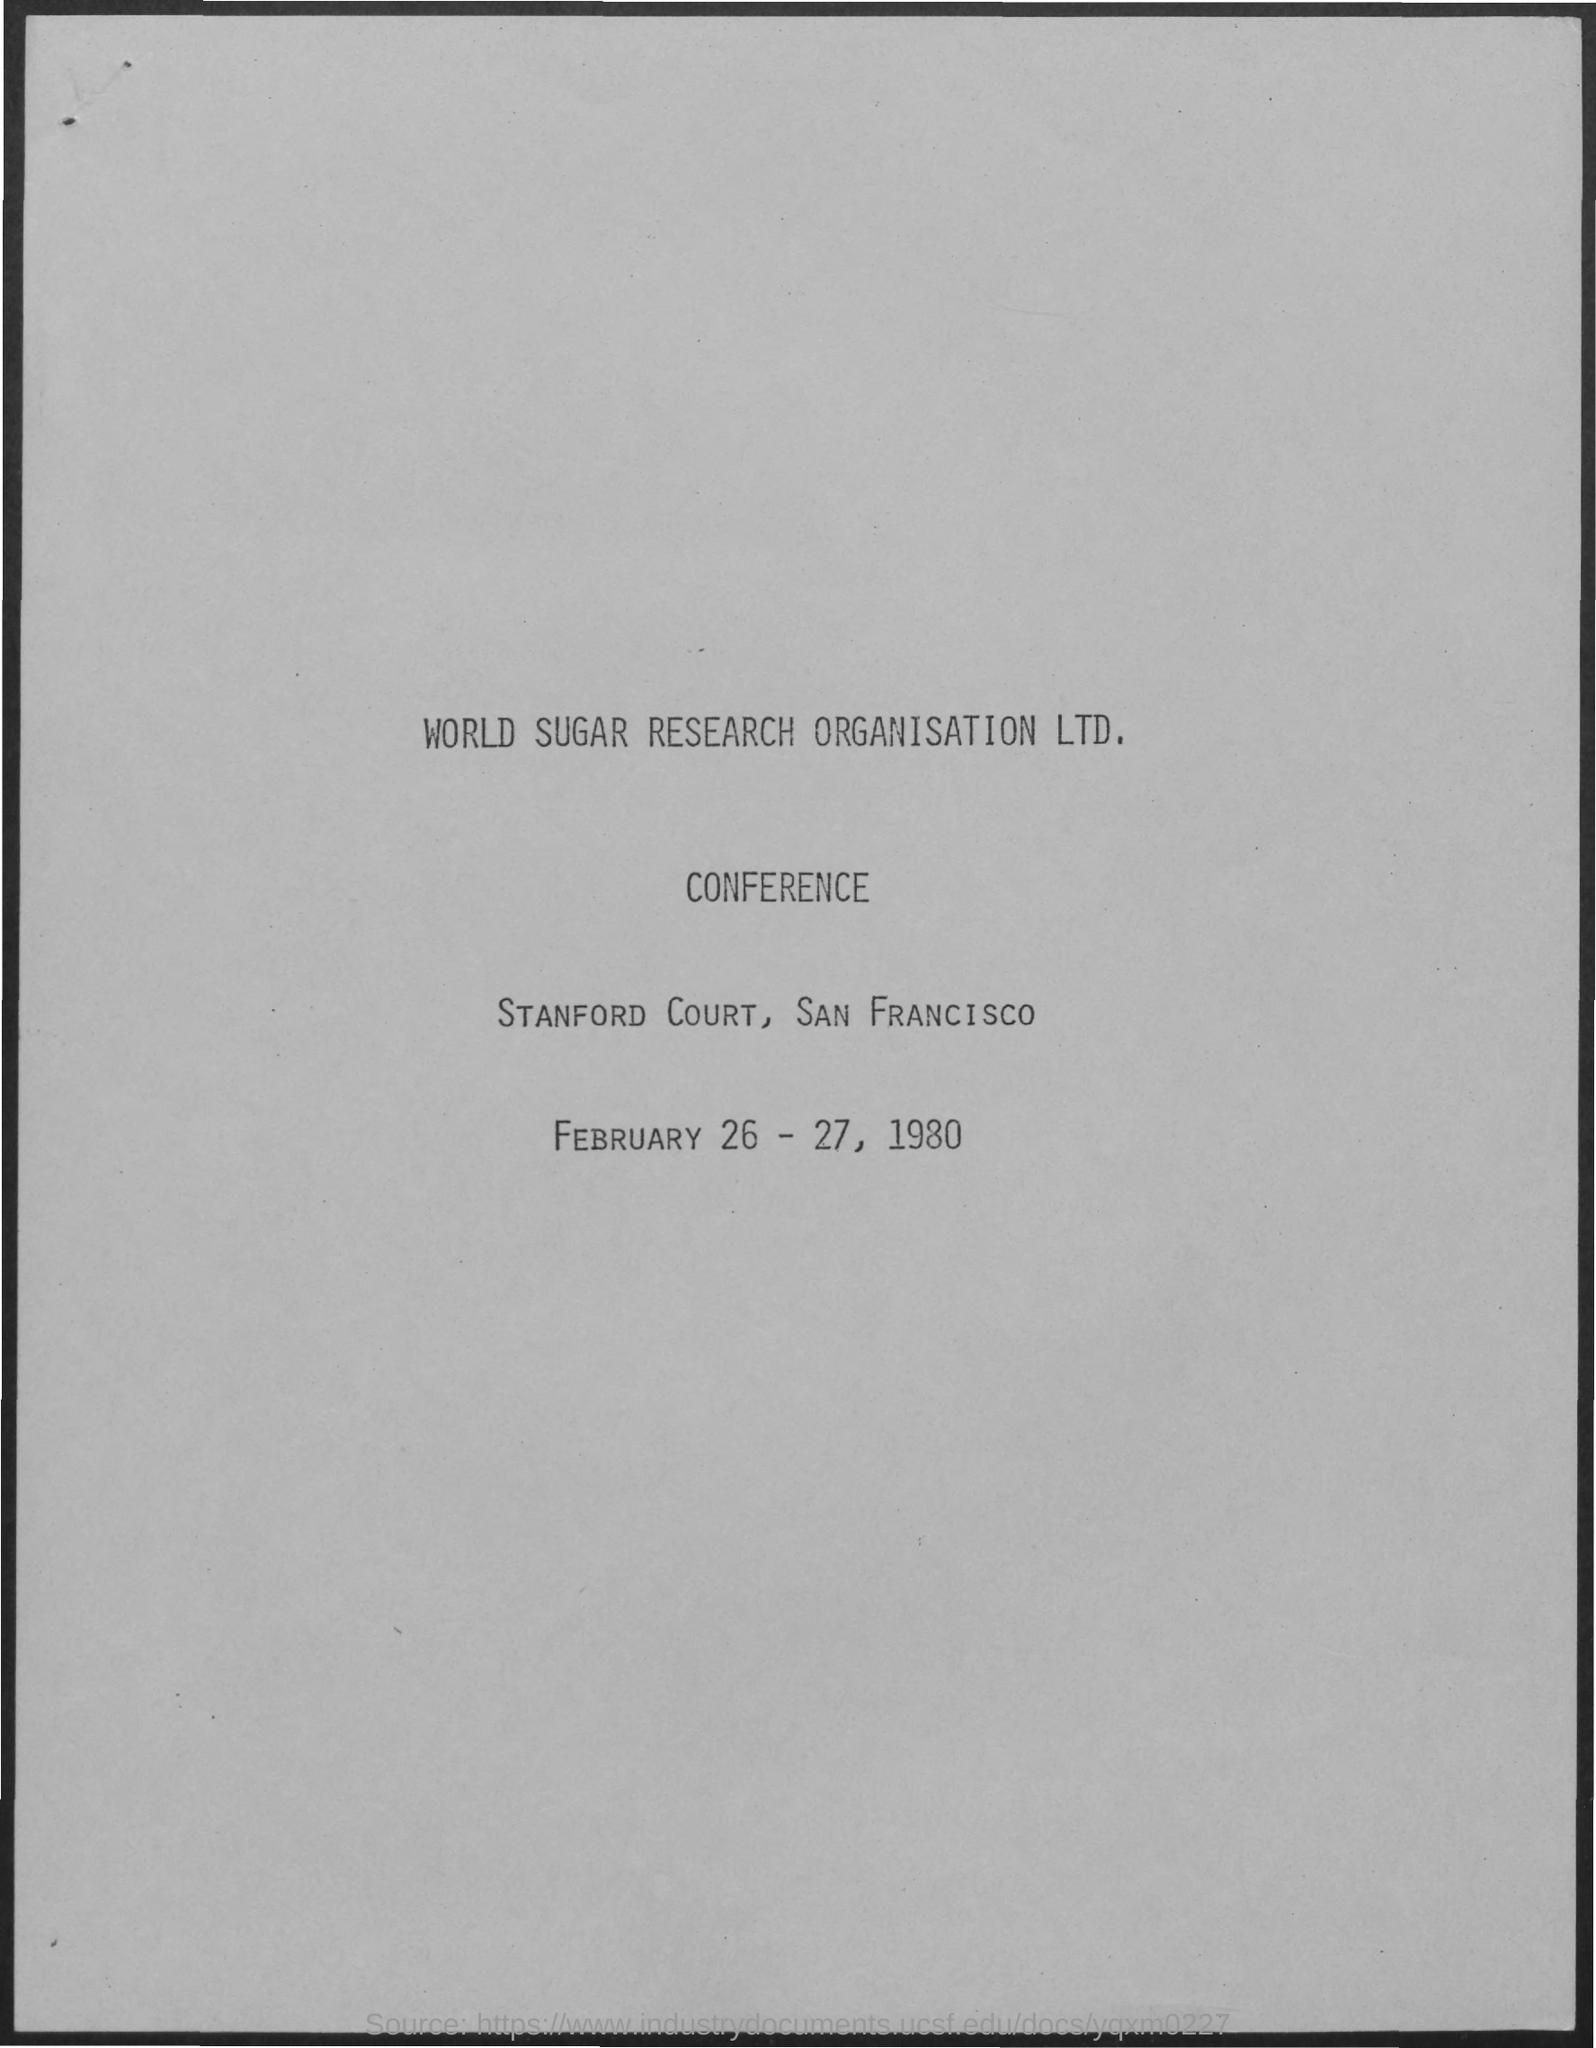Specify some key components in this picture. The Conference of World Sugar Research Organisation Ltd. is held annually at Stanford Court in San Francisco. The Conference of the World Sugar Research Organisation Ltd. was held on February 26 and 27, 1980. 